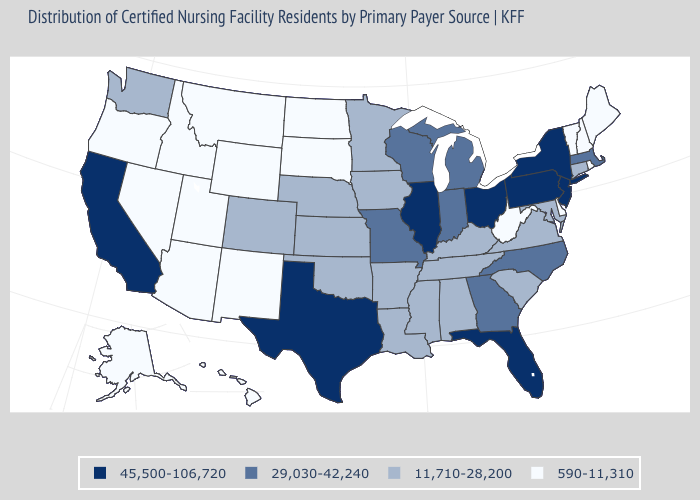What is the value of Colorado?
Quick response, please. 11,710-28,200. Name the states that have a value in the range 11,710-28,200?
Give a very brief answer. Alabama, Arkansas, Colorado, Connecticut, Iowa, Kansas, Kentucky, Louisiana, Maryland, Minnesota, Mississippi, Nebraska, Oklahoma, South Carolina, Tennessee, Virginia, Washington. What is the value of Utah?
Be succinct. 590-11,310. Name the states that have a value in the range 11,710-28,200?
Concise answer only. Alabama, Arkansas, Colorado, Connecticut, Iowa, Kansas, Kentucky, Louisiana, Maryland, Minnesota, Mississippi, Nebraska, Oklahoma, South Carolina, Tennessee, Virginia, Washington. Does Nebraska have a higher value than Alaska?
Give a very brief answer. Yes. What is the highest value in states that border Colorado?
Short answer required. 11,710-28,200. Name the states that have a value in the range 590-11,310?
Quick response, please. Alaska, Arizona, Delaware, Hawaii, Idaho, Maine, Montana, Nevada, New Hampshire, New Mexico, North Dakota, Oregon, Rhode Island, South Dakota, Utah, Vermont, West Virginia, Wyoming. What is the lowest value in the MidWest?
Short answer required. 590-11,310. Which states have the lowest value in the South?
Concise answer only. Delaware, West Virginia. Name the states that have a value in the range 29,030-42,240?
Quick response, please. Georgia, Indiana, Massachusetts, Michigan, Missouri, North Carolina, Wisconsin. What is the value of Louisiana?
Concise answer only. 11,710-28,200. What is the value of Virginia?
Keep it brief. 11,710-28,200. What is the highest value in the West ?
Concise answer only. 45,500-106,720. Name the states that have a value in the range 11,710-28,200?
Quick response, please. Alabama, Arkansas, Colorado, Connecticut, Iowa, Kansas, Kentucky, Louisiana, Maryland, Minnesota, Mississippi, Nebraska, Oklahoma, South Carolina, Tennessee, Virginia, Washington. Does the map have missing data?
Keep it brief. No. 